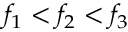<formula> <loc_0><loc_0><loc_500><loc_500>f _ { 1 } < f _ { 2 } < f _ { 3 }</formula> 